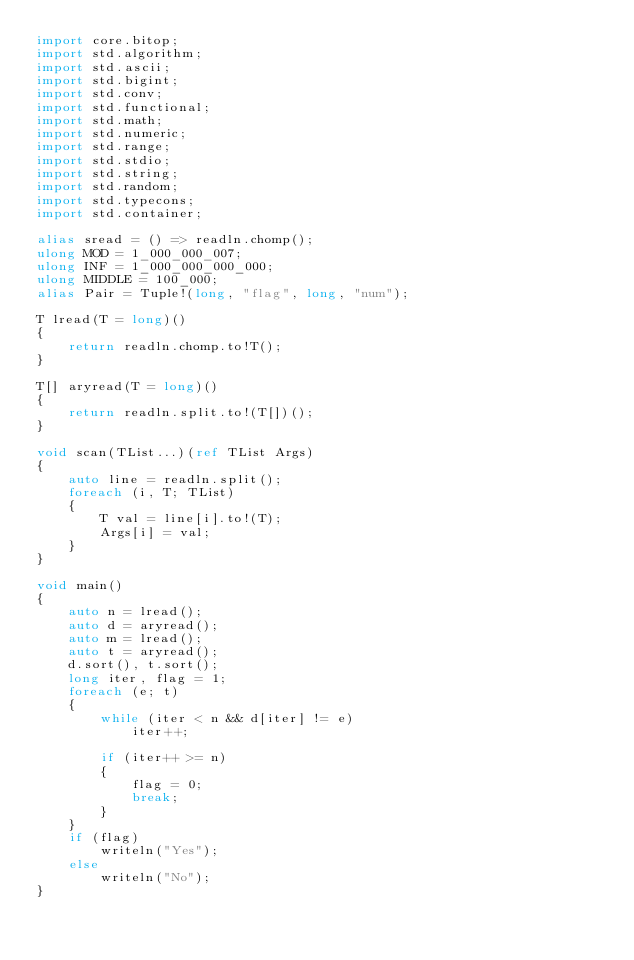Convert code to text. <code><loc_0><loc_0><loc_500><loc_500><_D_>import core.bitop;
import std.algorithm;
import std.ascii;
import std.bigint;
import std.conv;
import std.functional;
import std.math;
import std.numeric;
import std.range;
import std.stdio;
import std.string;
import std.random;
import std.typecons;
import std.container;

alias sread = () => readln.chomp();
ulong MOD = 1_000_000_007;
ulong INF = 1_000_000_000_000;
ulong MIDDLE = 100_000;
alias Pair = Tuple!(long, "flag", long, "num");

T lread(T = long)()
{
    return readln.chomp.to!T();
}

T[] aryread(T = long)()
{
    return readln.split.to!(T[])();
}

void scan(TList...)(ref TList Args)
{
    auto line = readln.split();
    foreach (i, T; TList)
    {
        T val = line[i].to!(T);
        Args[i] = val;
    }
}

void main()
{
    auto n = lread();
    auto d = aryread();
    auto m = lread();
    auto t = aryread();
    d.sort(), t.sort();
    long iter, flag = 1;
    foreach (e; t)
    {
        while (iter < n && d[iter] != e)
            iter++;

        if (iter++ >= n)
        {
            flag = 0;
            break;
        }
    }
    if (flag)
        writeln("Yes");
    else
        writeln("No");
}
</code> 